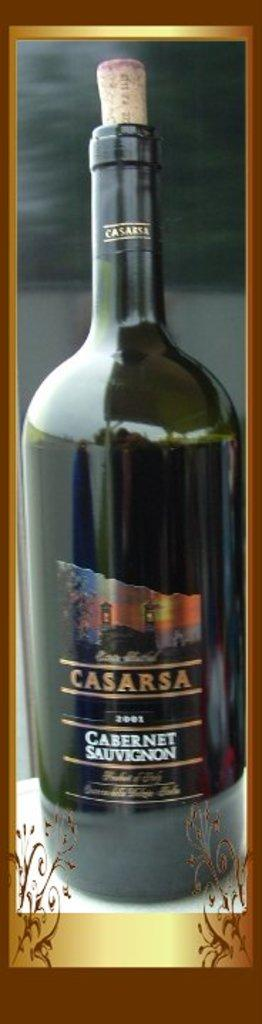<image>
Share a concise interpretation of the image provided. a bottle of Casarsa Cabernet Sauvignon wine in a frame 